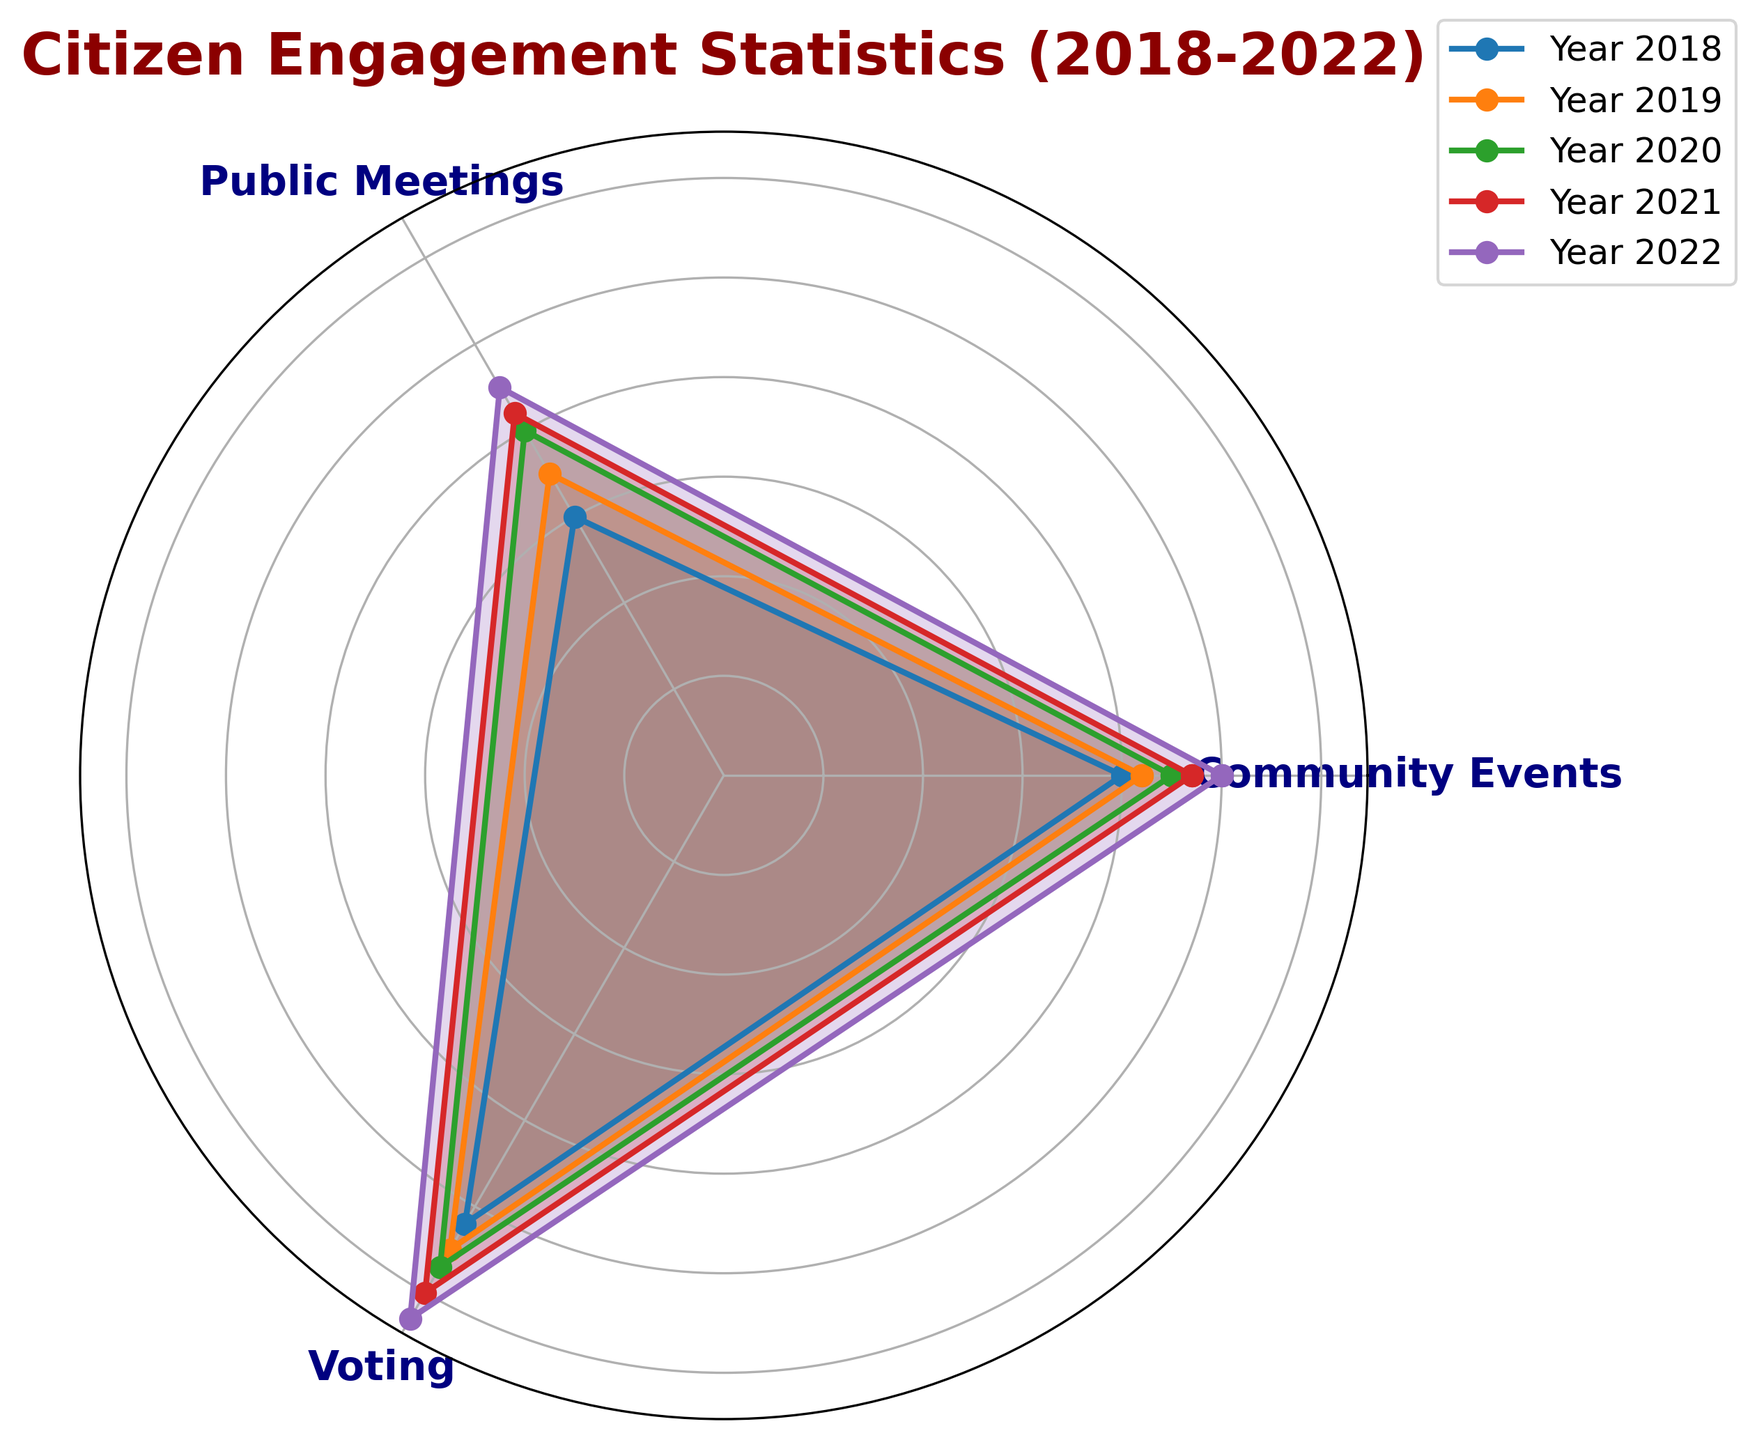What was the participation trend in Public Meetings from 2018 to 2022? The radar chart shows the participation increasing over time. Specifically, participation in Public Meetings rose from 30 in 2018 to 45 in 2022.
Answer: Increasing trend Which category had the highest participation in 2022? By looking at the radar chart for 2022, Voting had the highest participation at 63.
Answer: Voting Was the participation in Community Events in 2021 higher than in 2019? The radar chart shows that Community Events had a participation rate of 47 in 2021 and 42 in 2019, indicating an increase.
Answer: Yes What has been the average participation rate in Voting over the years from 2018 to 2022? To find the average: (52 + 55 + 57 + 60 + 63) / 5 = 57.4
Answer: 57.4 Compare the participation increase in Public Meetings versus Community Events from 2018 to 2022. In Public Meetings, the increase was from 30 to 45, totaling an increase of 15. For Community Events, it went from 40 to 50, totaling an increase of 10.
Answer: Public Meetings What was the participation rate in Voting for the year with the highest overall participation rate in Community Events? The highest participation in Community Events was in 2022 with a rate of 50. The corresponding rate in Voting that year was 63.
Answer: 63 Which category showed the least variability in participation from 2018 to 2022? By visually inspecting the radar chart, all three years’ distances from the center can be compared. Community Events showed the least range in values, ranging only from 40 to 50.
Answer: Community Events Are there any years where the participation in Public Meetings intersected with Community Events on the radar chart? By examining the intersections on the radar chart each year, there are no intersections, indicating that Public Meetings and Community Events did not have the same values at any point.
Answer: No Compare the rate of increase in participation between Voting and Public Meetings from 2018 to 2022. The increase for Voting was 63 - 52 = 11. For Public Meetings, it was 45 - 30 = 15. Therefore, Public Meetings had a greater increase in participation rate.
Answer: Public Meetings Assuming the trend continues, what would be the forecasted participation rate for Community Events in 2023? The average increase for Community Events each year is (42-40 + 45-42 + 47-45 + 50-47) / 4 = 2. Assuming this trend continues, the forecasted participation rate for 2023 would be 50 + 2 = 52.
Answer: 52 